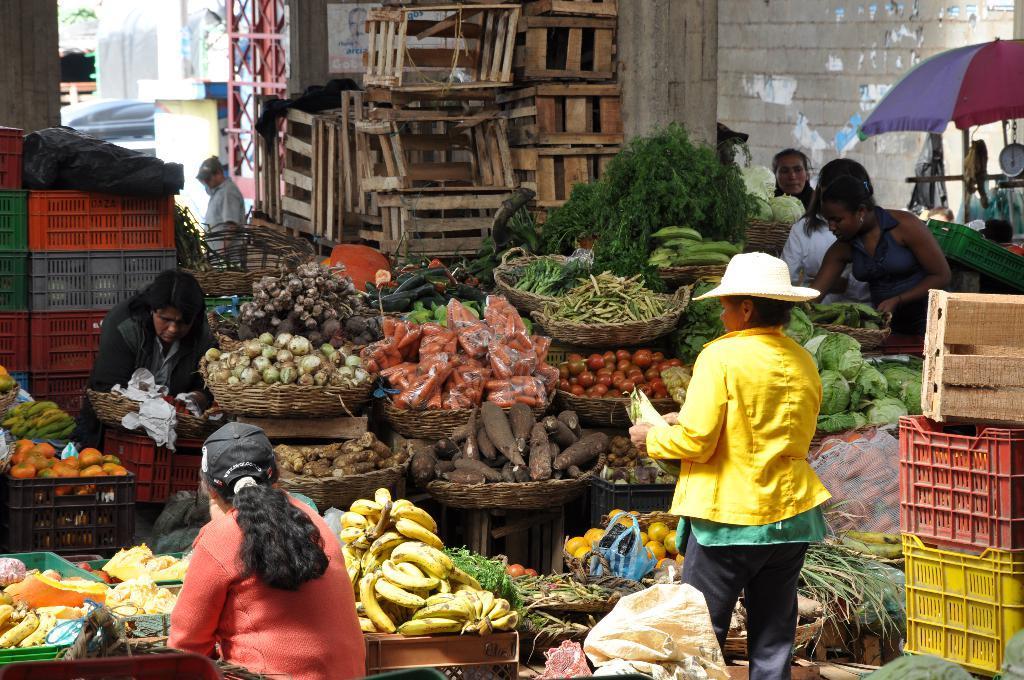Can you describe this image briefly? As we can see in the image there is a wall, boxes, vegetables, trees, baskets, few people here and there, an umbrella and buildings. 